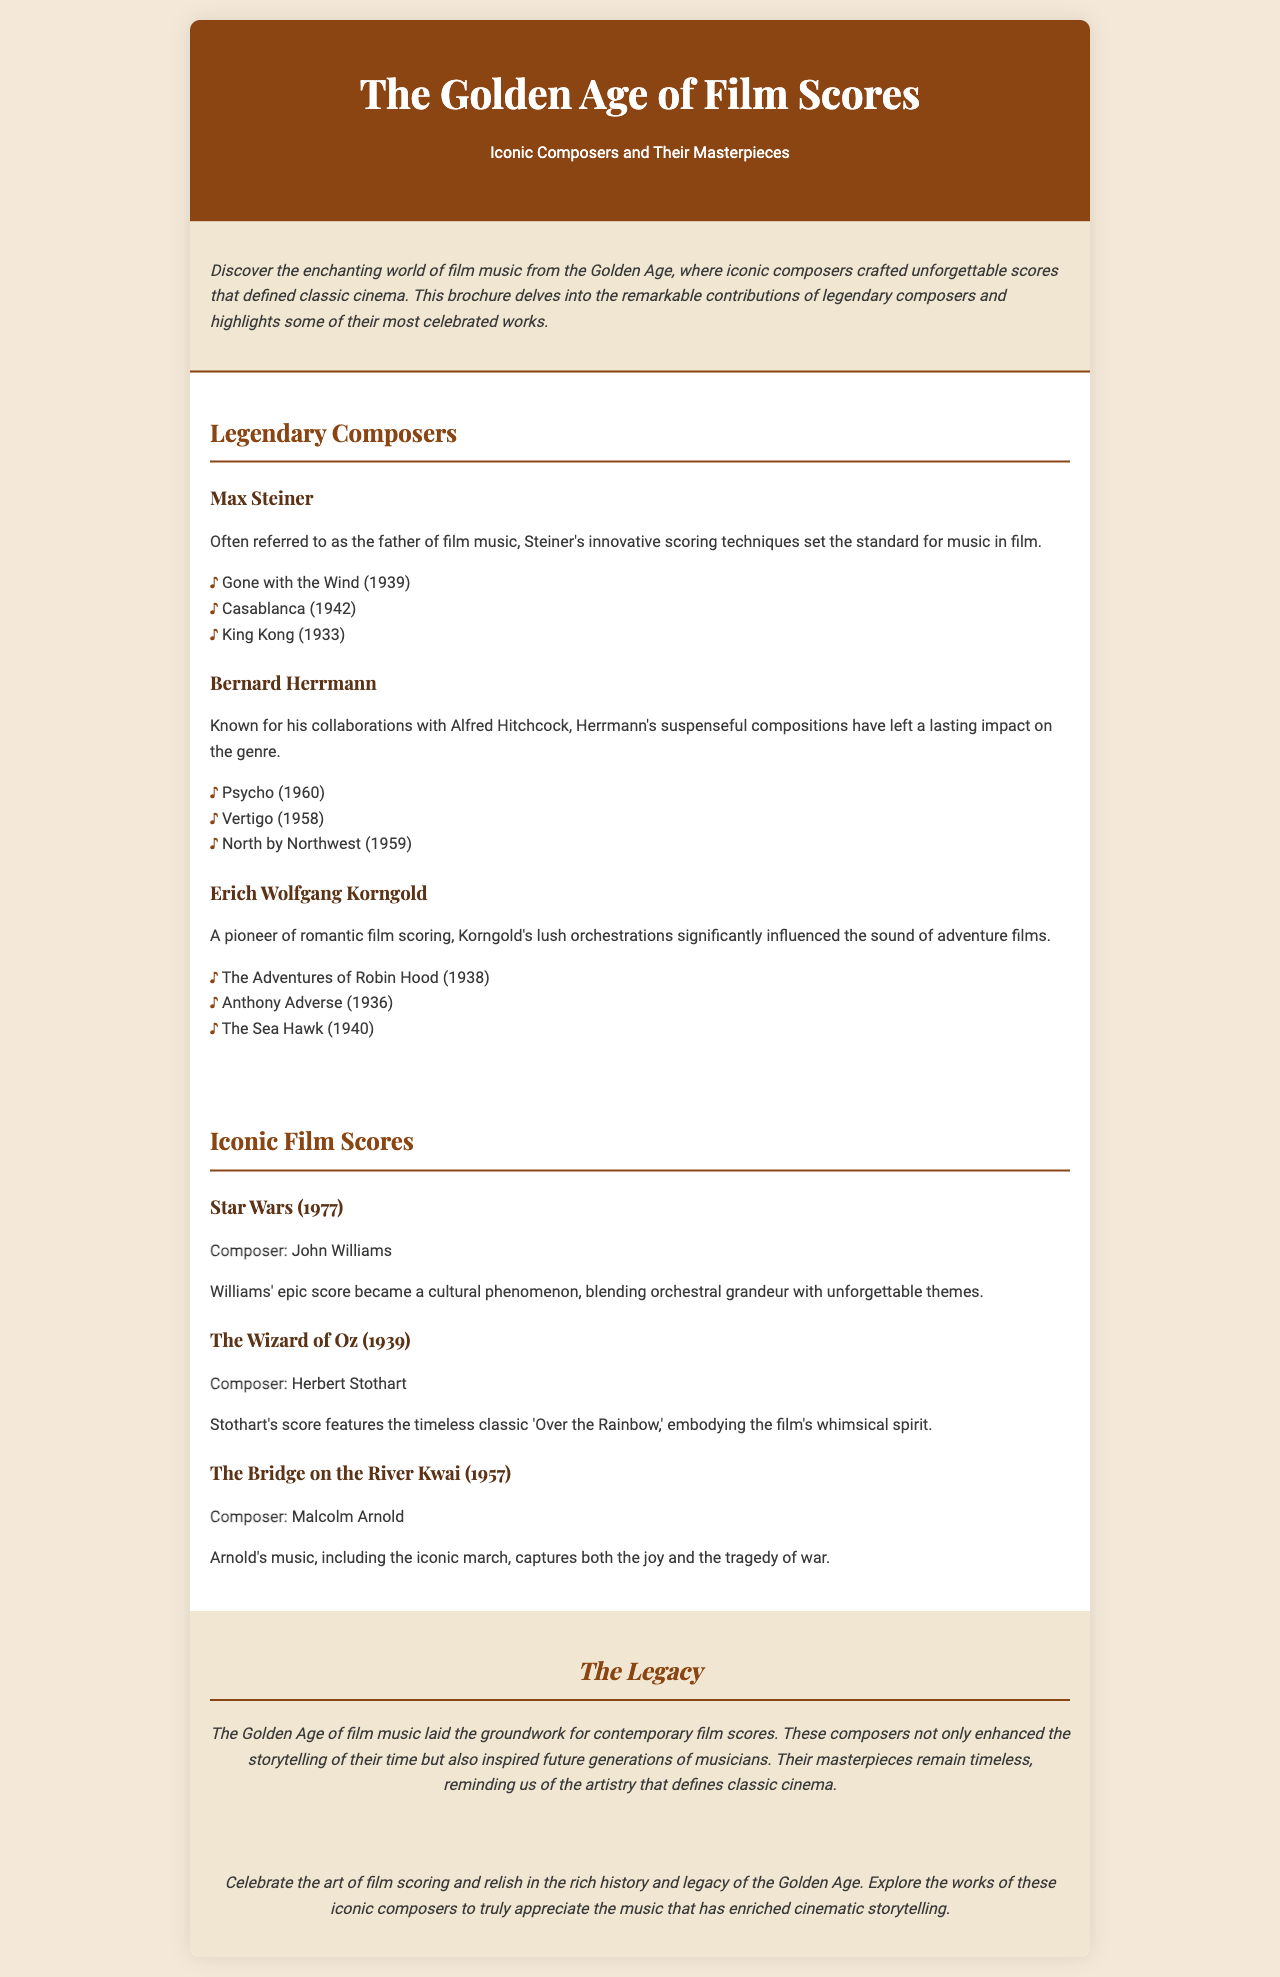What is the title of the brochure? The title is prominently displayed at the top of the document, identifying the main topic of the content.
Answer: The Golden Age of Film Scores Who is considered the father of film music? The document mentions a specific composer who is referred to as the father of film music, emphasizing his influence and contributions.
Answer: Max Steiner Which film score features the theme 'Over the Rainbow'? The document identifies a specific film and its composer that includes this iconic musical piece as part of its score.
Answer: The Wizard of Oz How many films did Bernard Herrmann compose music for as mentioned? The document lists three notable films that Bernard Herrmann scored, allowing for a count based on the information provided.
Answer: 3 What year was 'Gone with the Wind' released? The document states the year of release alongside a specific composer associated with the film, providing a straightforward answer from the listed information.
Answer: 1939 What is the significance of the Golden Age of film music? The document describes the impact and influence of this era on contemporary film scores and future composers, summarizing its legacy succinctly.
Answer: Laid the groundwork for contemporary film scores Which composer is associated with 'Star Wars'? The document clearly specifies which composer created the music for this particular iconic film, making it a direct retrieval question.
Answer: John Williams What color is the background of the brochure? The document describes the background color used throughout the brochure, which sets the visual tone for the content presented.
Answer: #f4e9d8 